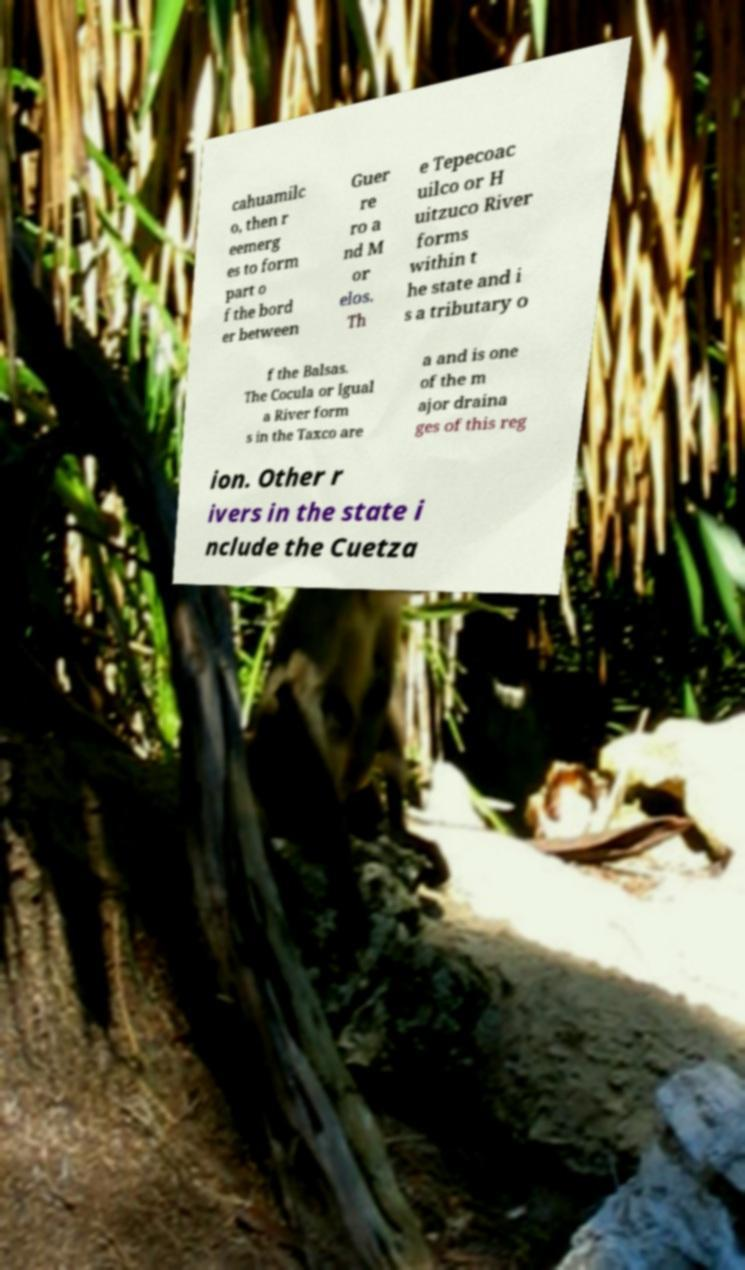Could you extract and type out the text from this image? cahuamilc o, then r eemerg es to form part o f the bord er between Guer re ro a nd M or elos. Th e Tepecoac uilco or H uitzuco River forms within t he state and i s a tributary o f the Balsas. The Cocula or Igual a River form s in the Taxco are a and is one of the m ajor draina ges of this reg ion. Other r ivers in the state i nclude the Cuetza 